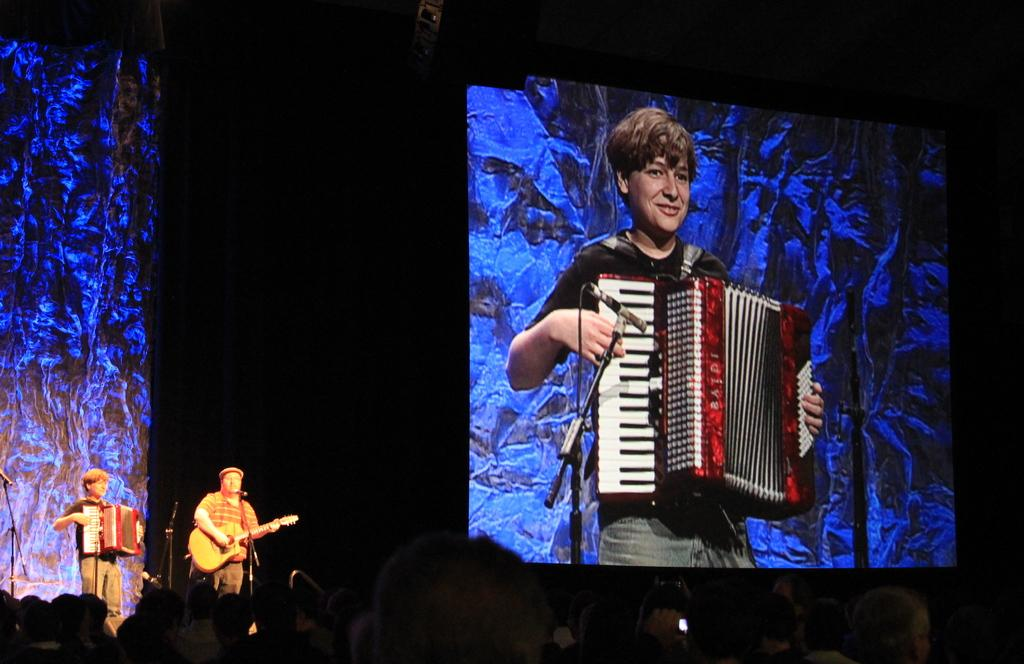What can be seen in the background of the image? There is a screen in the background of the image. What is the person in the background doing? The person in the background is playing a musical instrument. How many persons are standing in front of the microphone? There are two persons standing in front of the microphone. What are the two persons doing in front of the microphone? Both persons are playing musical instruments. How many fairies are playing the drum in the image? There are no fairies or drums present in the image. What is the income of the person playing the musical instrument in the image? The income of the person playing the musical instrument cannot be determined from the image. 